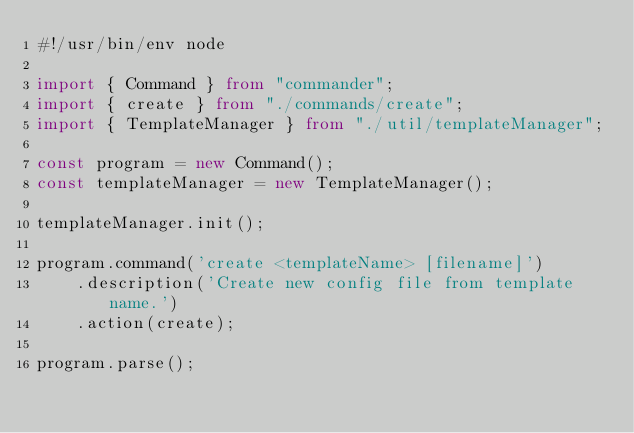<code> <loc_0><loc_0><loc_500><loc_500><_TypeScript_>#!/usr/bin/env node

import { Command } from "commander";
import { create } from "./commands/create";
import { TemplateManager } from "./util/templateManager";

const program = new Command();
const templateManager = new TemplateManager();

templateManager.init();

program.command('create <templateName> [filename]')
    .description('Create new config file from template name.')
    .action(create);

program.parse();
</code> 